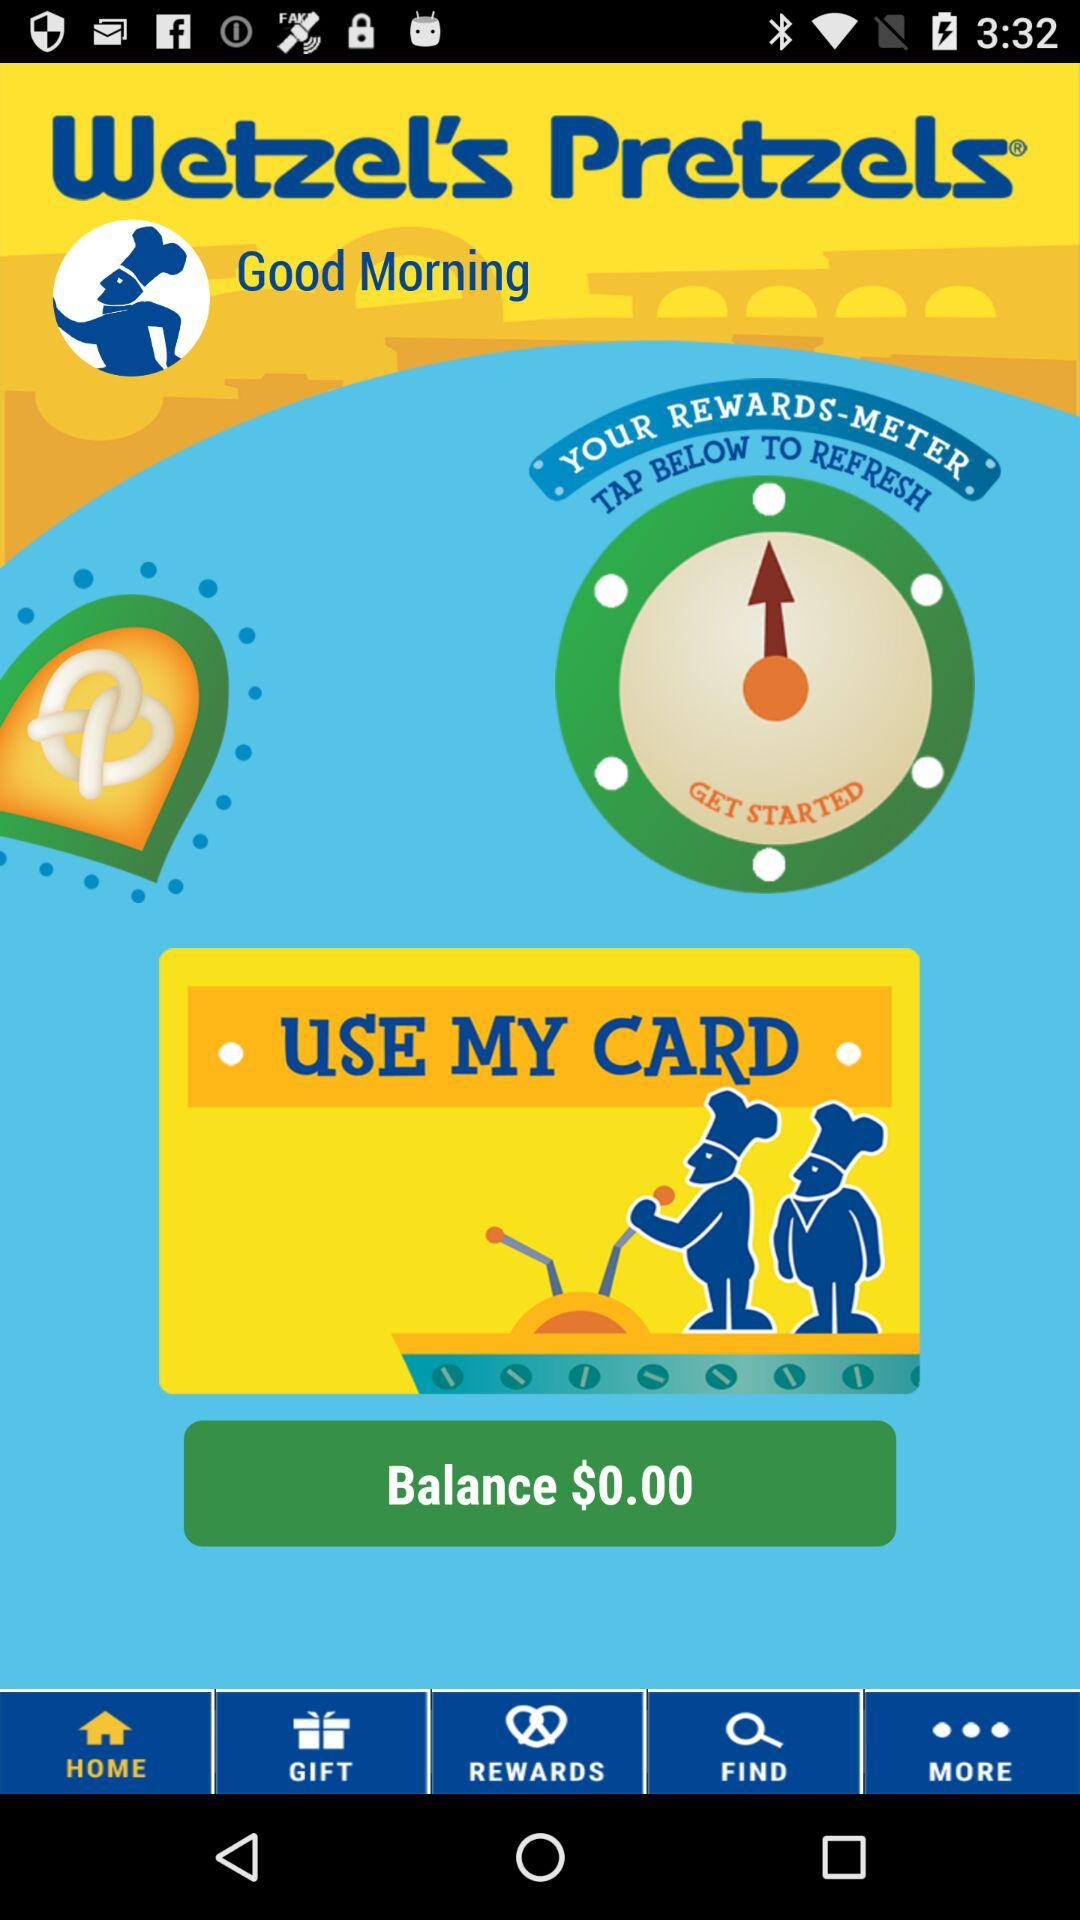How much is the balance on the user's card?
Answer the question using a single word or phrase. $0.00 